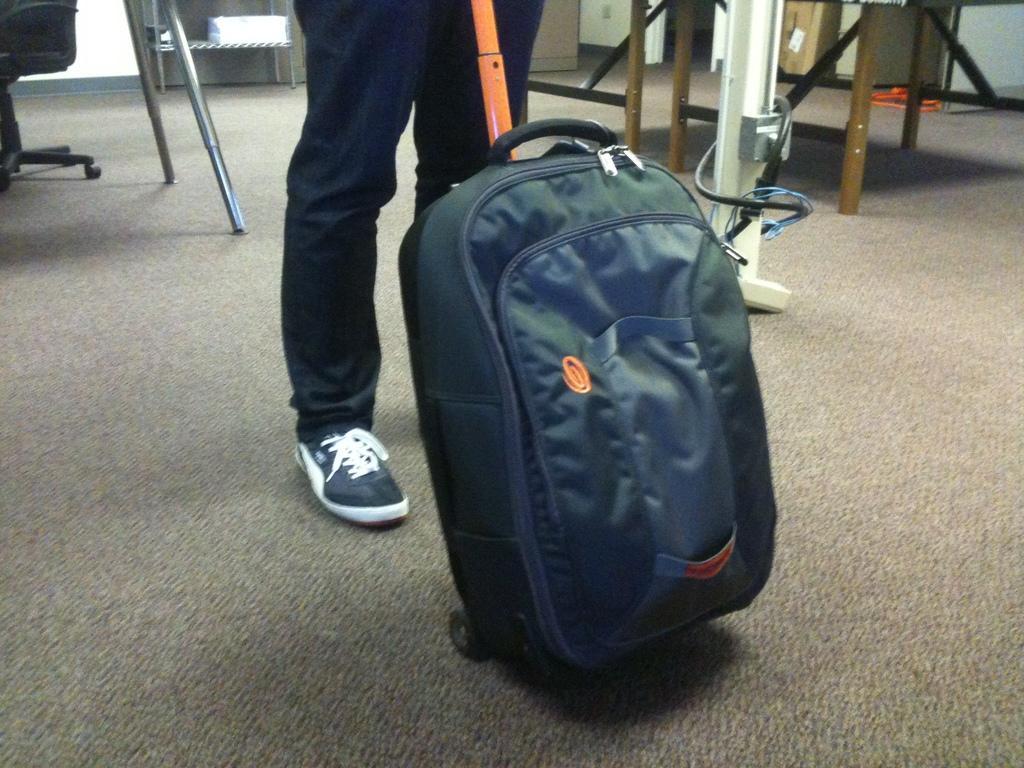Can you describe this image briefly? In this picture, we see a bag which is in grey color is having orange handle and it is holding by the man. Behind behind the bag, we see man in blue pant is standing and beside him, we see many chairs and tables and in front of the picture, we see grey carpet on the floor. 